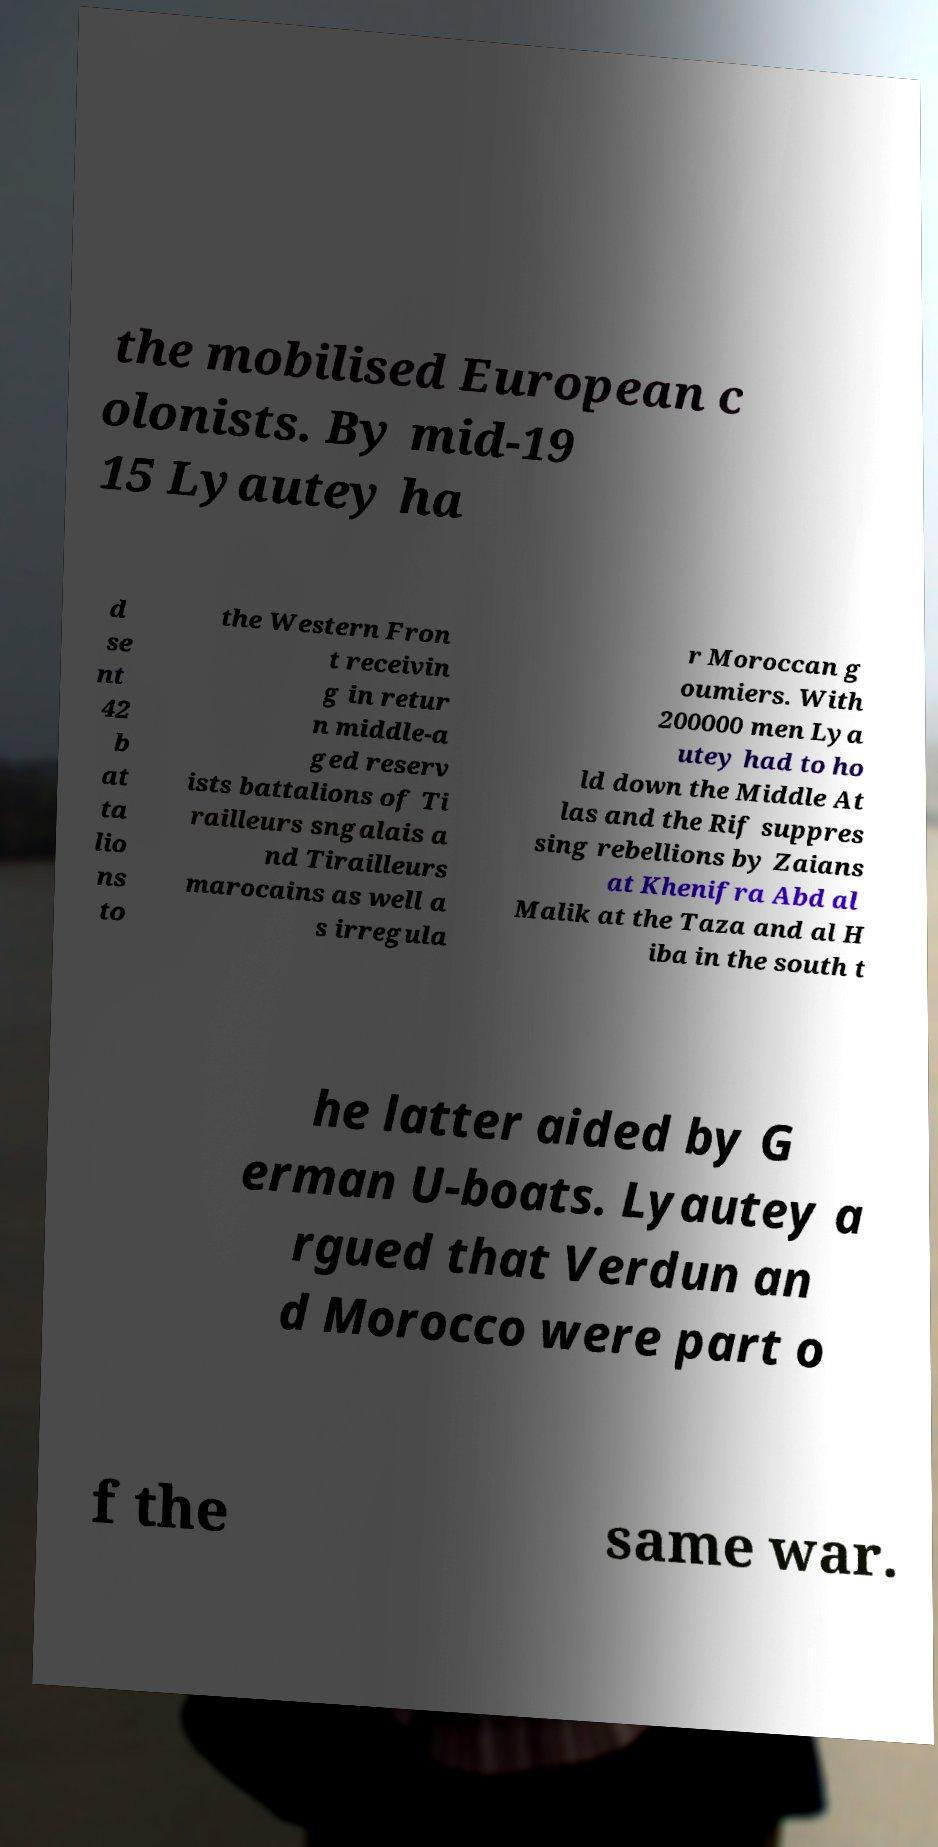Could you extract and type out the text from this image? the mobilised European c olonists. By mid-19 15 Lyautey ha d se nt 42 b at ta lio ns to the Western Fron t receivin g in retur n middle-a ged reserv ists battalions of Ti railleurs sngalais a nd Tirailleurs marocains as well a s irregula r Moroccan g oumiers. With 200000 men Lya utey had to ho ld down the Middle At las and the Rif suppres sing rebellions by Zaians at Khenifra Abd al Malik at the Taza and al H iba in the south t he latter aided by G erman U-boats. Lyautey a rgued that Verdun an d Morocco were part o f the same war. 